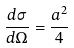<formula> <loc_0><loc_0><loc_500><loc_500>\frac { d \sigma } { d \Omega } = \frac { a ^ { 2 } } { 4 }</formula> 